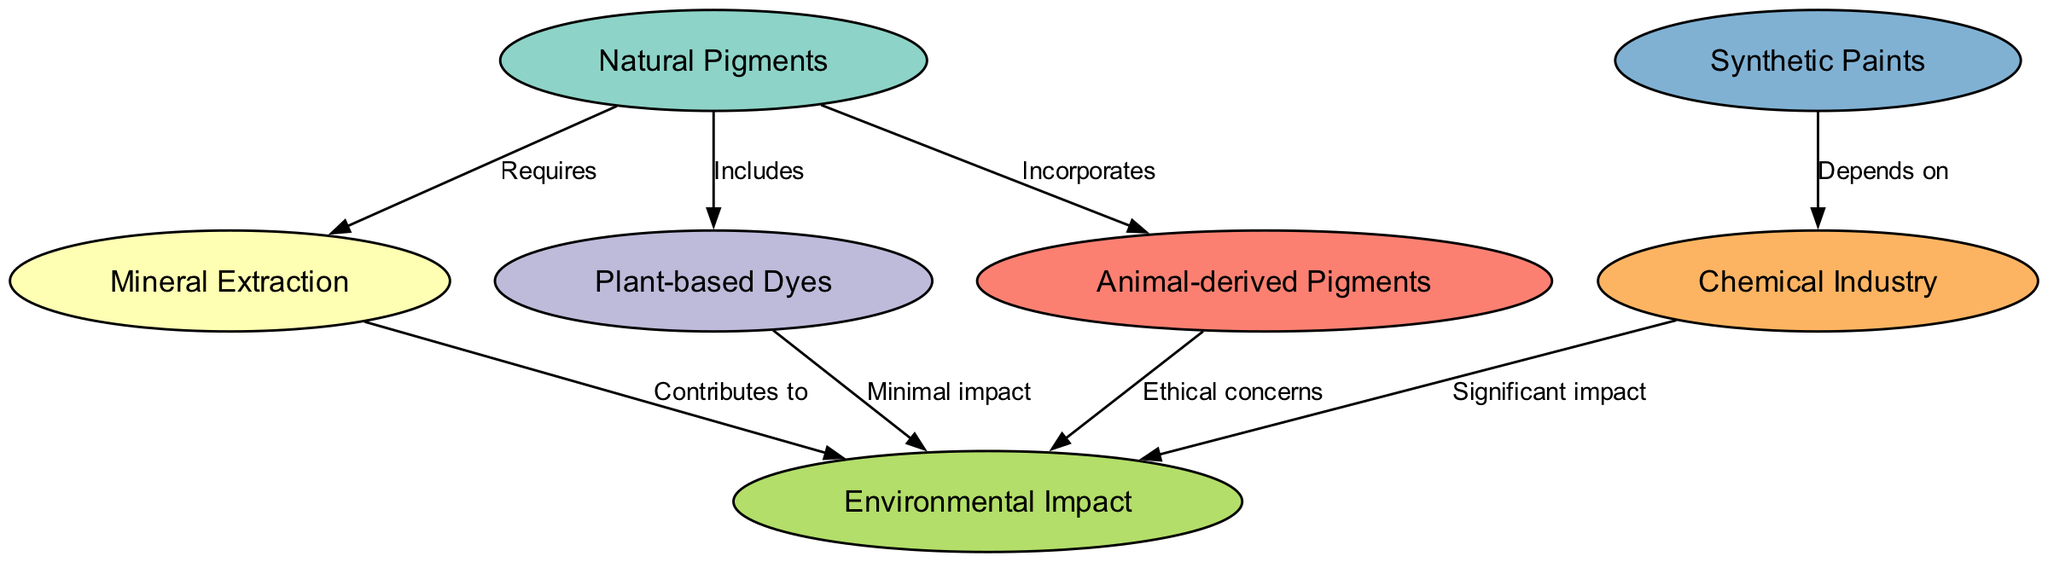What are the three types of pigments represented in the diagram? The diagram includes Natural Pigments, Animal-derived Pigments, and Plant-based Dyes as part of the nodes. These are listed as essential components of art materials.
Answer: Natural Pigments, Animal-derived Pigments, Plant-based Dyes How many edges connect to the "Environmental Impact" node? The "Environmental Impact" node has three incoming edges, representing the contributions and impacts from Mineral Extraction, Plant-based Dyes, and Animal-derived Pigments.
Answer: 3 What does "Natural Pigments" require? According to the diagram, "Natural Pigments" has an edge labeled "Requires" that points to "Mineral Extraction", indicating that natural pigments necessitate mineral resources for their production.
Answer: Mineral Extraction What is the relationship between "Synthetic Paints" and "Chemical Industry"? The diagram shows a directed edge from "Synthetic Paints" to "Chemical Industry" labeled "Depends on," which indicates that the production or formulation of synthetic paints relies on the processes or materials from the chemical industry.
Answer: Depends on Which pigment type has minimal environmental impact? The diagram indicates that "Plant-based Dyes" directly connect with "Environmental Impact" through an edge labeled "Minimal impact," suggesting that compared to other pigment sources, plant-based dyes have less negative influence on the environment.
Answer: Minimal impact Which aspect of "Animal-derived Pigments" raises ethical concerns? "Animal-derived Pigments" has an edge leading to "Environmental Impact" labeled "Ethical concerns," indicating that while these pigments may be useful, the processes involved in obtaining them can raise ethical or moral dilemmas tied to animal welfare and sustainability.
Answer: Ethical concerns How does the "Chemical Industry" affect the environment? The diagram illustrated a relationship where "Chemical Industry" contributes significantly to "Environmental Impact," showing that activities associated with this industry have notable negative consequences for the environment.
Answer: Significant impact Which category includes 'Mineral Extraction'? The node "Mineral Extraction" is linked to "Natural Pigments" with an edge labeled "Requires," suggesting it is an essential category related to the production of natural pigments in the framework of art materials.
Answer: Natural Pigments 